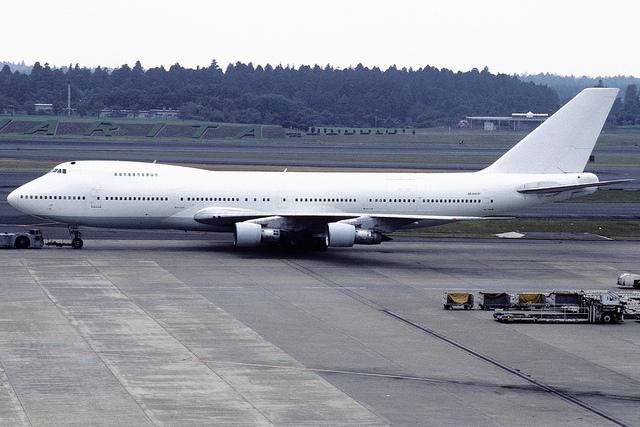Why is the plane unmarked?
Concise answer only. Private plane. Is this a commercial airline?
Quick response, please. Yes. How many engines on the plane?
Concise answer only. 4. 